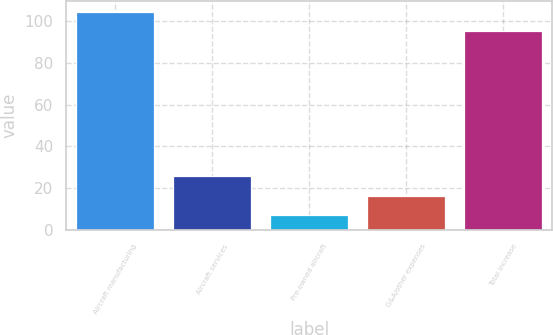Convert chart to OTSL. <chart><loc_0><loc_0><loc_500><loc_500><bar_chart><fcel>Aircraft manufacturing<fcel>Aircraft services<fcel>Pre-owned aircraft<fcel>G&A/other expenses<fcel>Total increase<nl><fcel>104.3<fcel>25.6<fcel>7<fcel>16.3<fcel>95<nl></chart> 